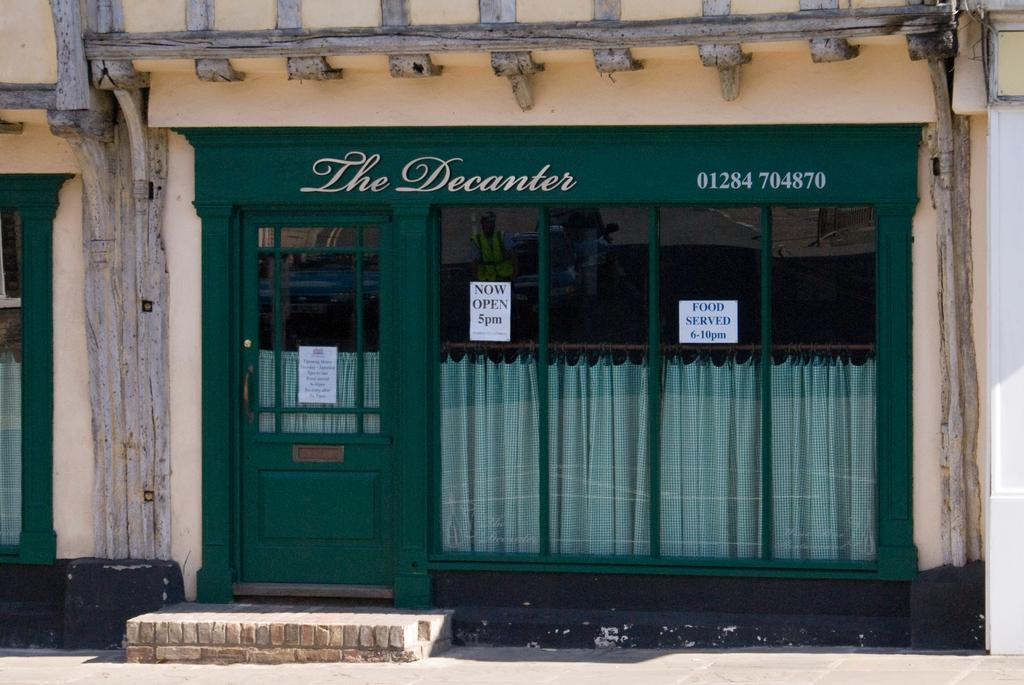What type of structure can be seen in the background of the image? There is a building in the background of the image. What feature is present in the image that allows access to the building? There is a door in the image. What surface is visible at the bottom of the image? There is a floor visible at the bottom of the image. What type of roof can be seen on the building in the image? The image does not show the roof of the building, so it cannot be determined from the image. 